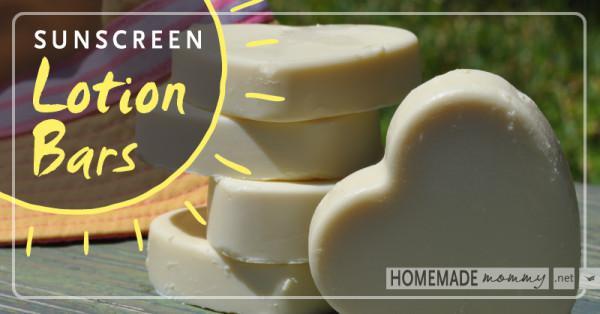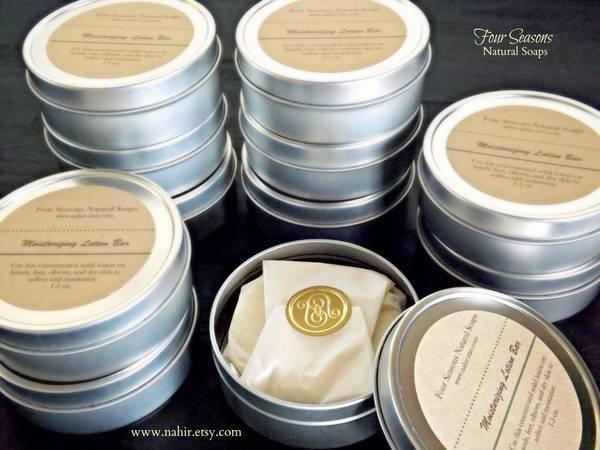The first image is the image on the left, the second image is the image on the right. Assess this claim about the two images: "An image includes multiple stacks of short silver containers with labels on top, and with only one unlidded.". Correct or not? Answer yes or no. Yes. The first image is the image on the left, the second image is the image on the right. Given the left and right images, does the statement "The lotion in one of the images is sitting in round tin containers." hold true? Answer yes or no. Yes. 